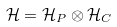Convert formula to latex. <formula><loc_0><loc_0><loc_500><loc_500>\mathcal { H } = \mathcal { H } _ { P } \otimes \mathcal { H } _ { C }</formula> 